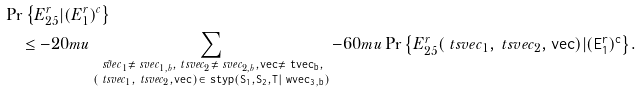<formula> <loc_0><loc_0><loc_500><loc_500>& \Pr \left \{ E _ { 2 5 } ^ { r } | ( E _ { 1 } ^ { r } ) ^ { c } \right \} \\ & \quad \leq { - 2 0 m u } \sum _ { \substack { \tilde { \ s v e c } _ { 1 } \neq \ s v e c _ { 1 , b } , \ t s v e c _ { 2 } \neq \ s v e c _ { 2 , b } , \tt v e c \ne \ t v e c _ { b } , \\ ( \ t s v e c _ { 1 } , \ t s v e c _ { 2 } , \tt v e c ) \in \ s t y p ( S _ { 1 } , S _ { 2 } , T | \ w v e c _ { 3 , b } ) } } { { - 6 0 m u } \Pr \left \{ E _ { 2 5 } ^ { r } ( \ t s v e c _ { 1 } , \ t s v e c _ { 2 } , \tt v e c ) | ( E _ { 1 } ^ { r } ) ^ { c } \right \} } .</formula> 